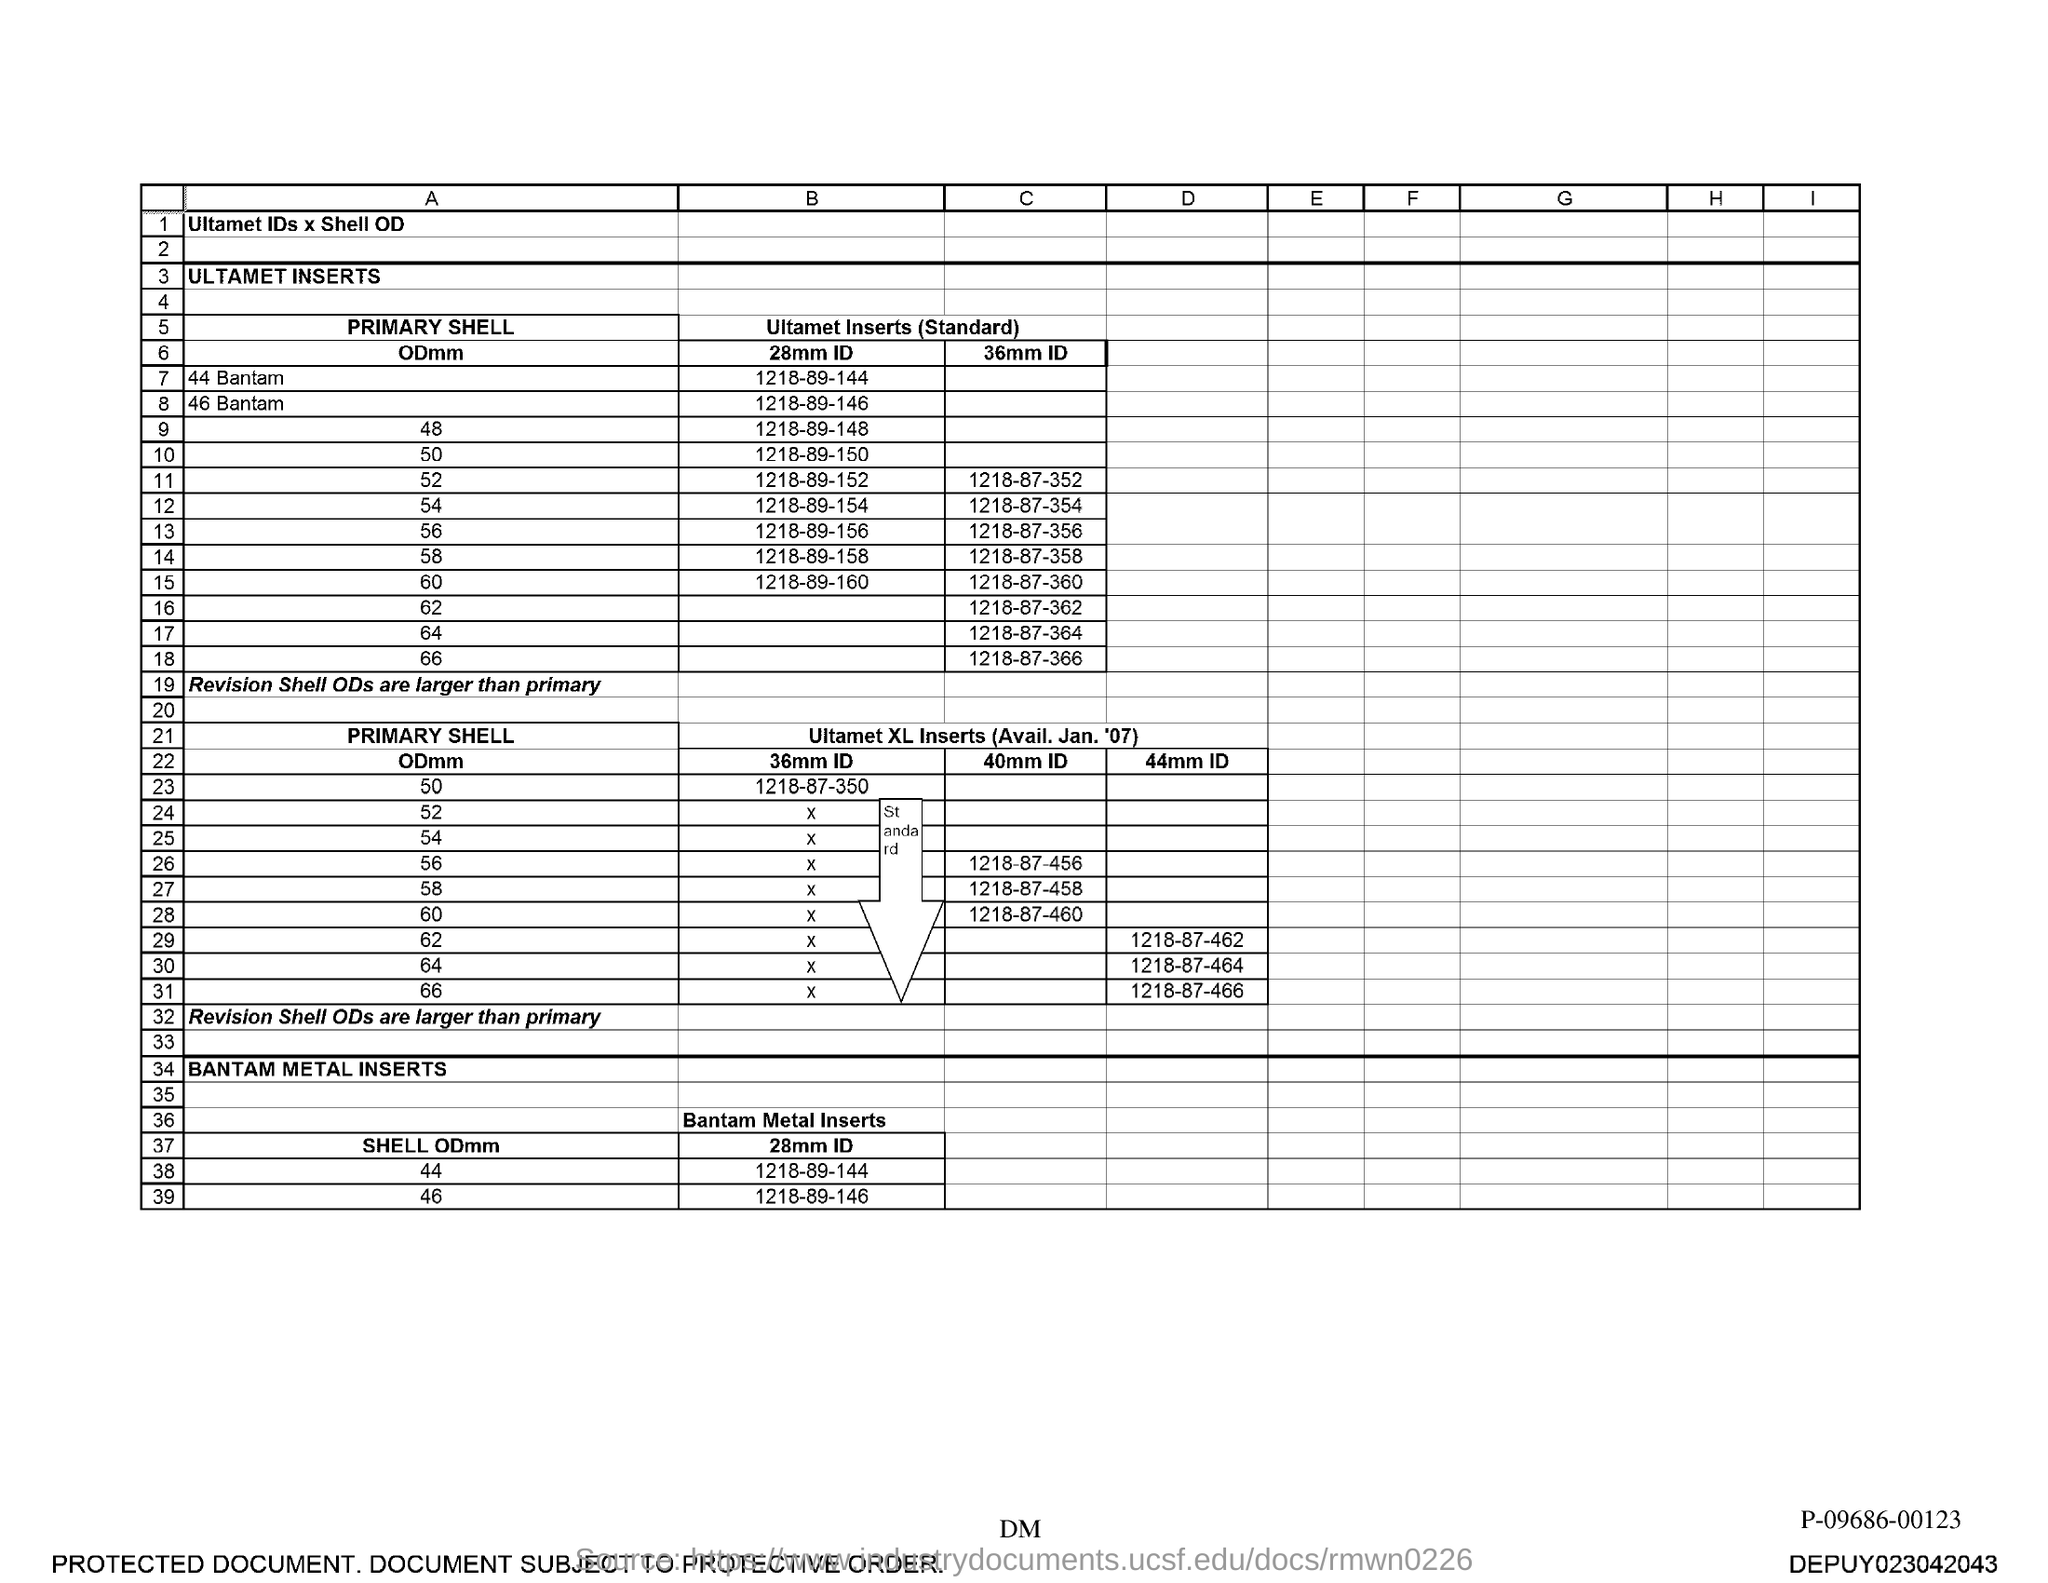Mention a couple of crucial points in this snapshot. The 28mm ID for a shell with an OD of 44 is 1218-89-144. 